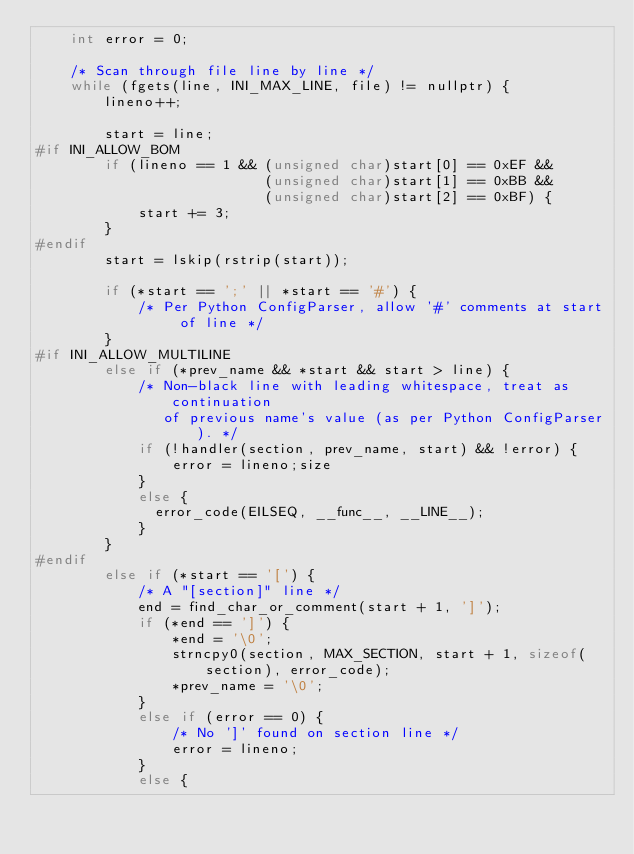Convert code to text. <code><loc_0><loc_0><loc_500><loc_500><_C++_>    int error = 0;

    /* Scan through file line by line */
    while (fgets(line, INI_MAX_LINE, file) != nullptr) {
        lineno++;

        start = line;
#if INI_ALLOW_BOM
        if (lineno == 1 && (unsigned char)start[0] == 0xEF &&
                           (unsigned char)start[1] == 0xBB &&
                           (unsigned char)start[2] == 0xBF) {
            start += 3;
        }
#endif
        start = lskip(rstrip(start));

        if (*start == ';' || *start == '#') {
            /* Per Python ConfigParser, allow '#' comments at start of line */
        }
#if INI_ALLOW_MULTILINE
        else if (*prev_name && *start && start > line) {
            /* Non-black line with leading whitespace, treat as continuation
               of previous name's value (as per Python ConfigParser). */
            if (!handler(section, prev_name, start) && !error) {
                error = lineno;size
            }
            else {
              error_code(EILSEQ, __func__, __LINE__);
            }
        }
#endif
        else if (*start == '[') {
            /* A "[section]" line */
            end = find_char_or_comment(start + 1, ']');
            if (*end == ']') {
                *end = '\0';
                strncpy0(section, MAX_SECTION, start + 1, sizeof(section), error_code);
                *prev_name = '\0';
            }
            else if (error == 0) {
                /* No ']' found on section line */
                error = lineno;
            }
            else {</code> 